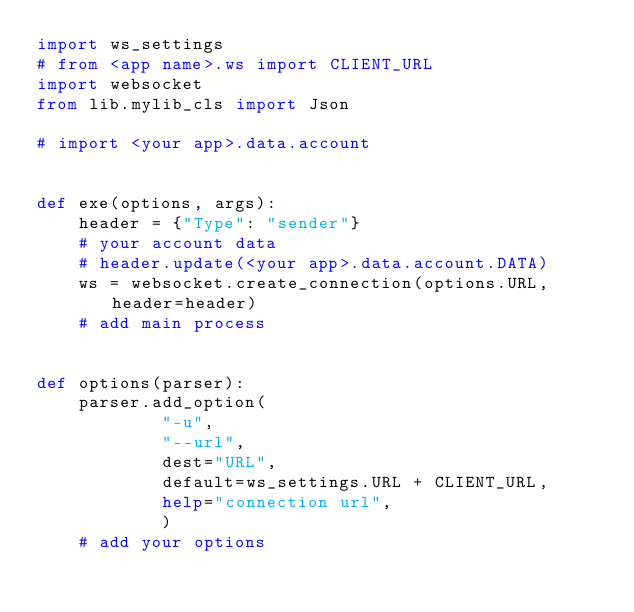Convert code to text. <code><loc_0><loc_0><loc_500><loc_500><_Python_>import ws_settings
# from <app name>.ws import CLIENT_URL
import websocket
from lib.mylib_cls import Json

# import <your app>.data.account


def exe(options, args):
    header = {"Type": "sender"}
    # your account data
    # header.update(<your app>.data.account.DATA)
    ws = websocket.create_connection(options.URL, header=header)
    # add main process


def options(parser):
    parser.add_option(
            "-u",
            "--url",
            dest="URL",
            default=ws_settings.URL + CLIENT_URL,
            help="connection url",
            )
    # add your options

</code> 